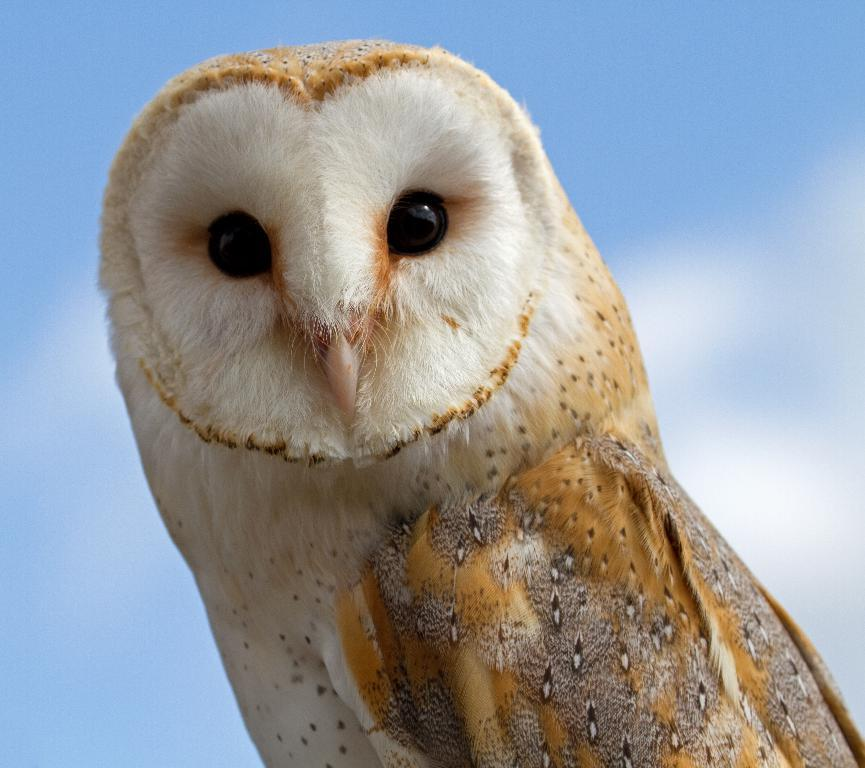What is the main subject in the center of the image? There is a bird in the center of the image. Can you describe the appearance of the bird? The bird has multi-color features. What can be seen in the background of the image? There is a sky visible in the background of the image, and clouds are present. What type of jeans is the bird wearing in the image? There are no jeans present in the image, as the bird is a living creature and does not wear clothing. 